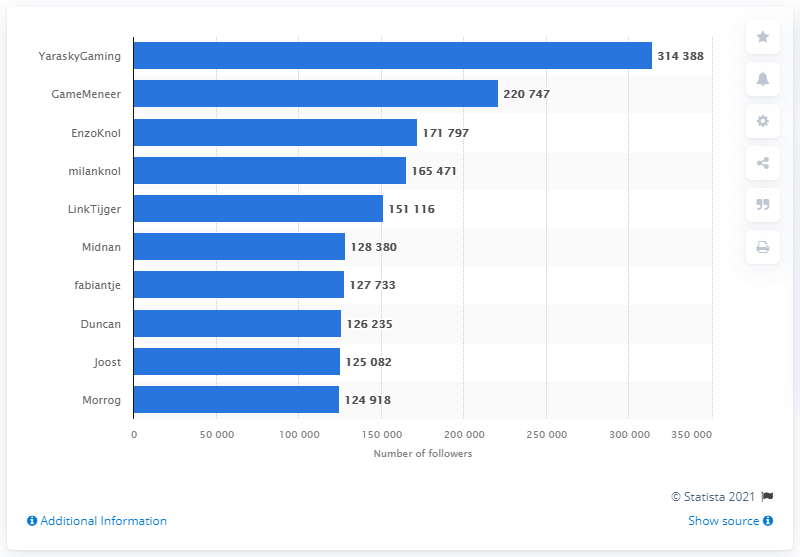Identify some key points in this picture. YaraskyGaming was the most-followed Twitch streamer from the Netherlands in March 2021. The sum of the two least followed streamers is 250,000. YaraskyGaming has the highest number of followers among all streamers. 